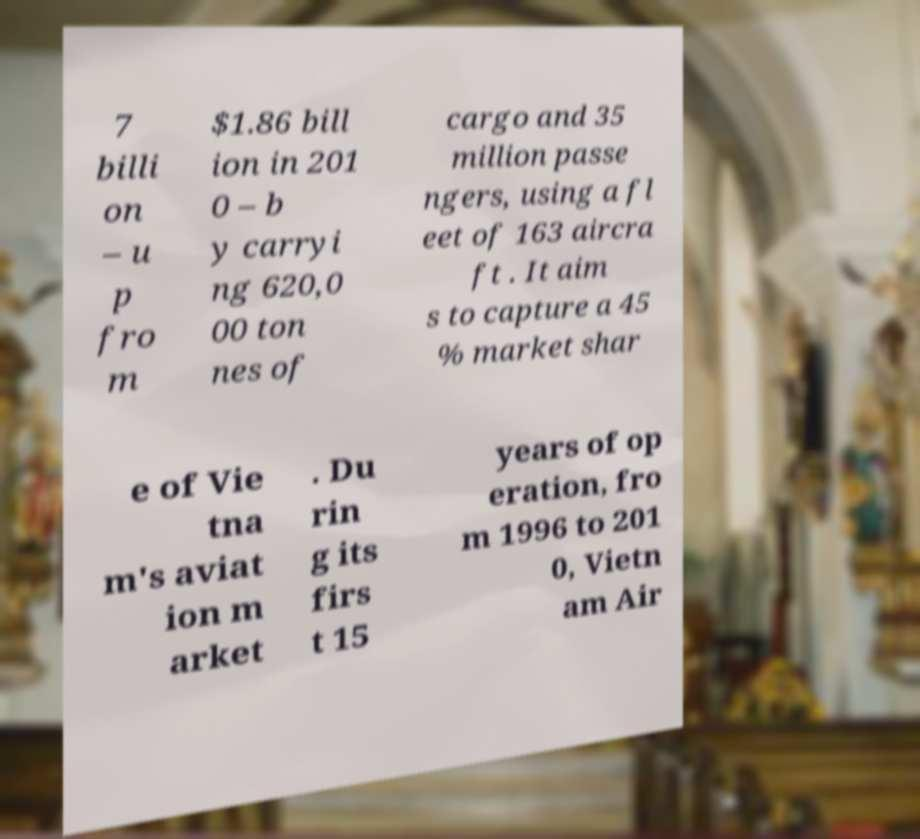Please read and relay the text visible in this image. What does it say? 7 billi on – u p fro m $1.86 bill ion in 201 0 – b y carryi ng 620,0 00 ton nes of cargo and 35 million passe ngers, using a fl eet of 163 aircra ft . It aim s to capture a 45 % market shar e of Vie tna m's aviat ion m arket . Du rin g its firs t 15 years of op eration, fro m 1996 to 201 0, Vietn am Air 